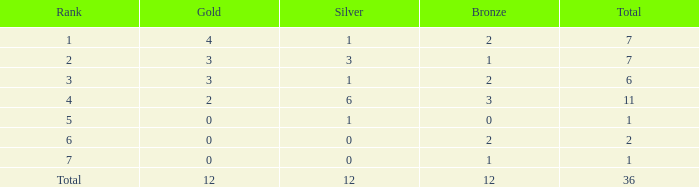Would you mind parsing the complete table? {'header': ['Rank', 'Gold', 'Silver', 'Bronze', 'Total'], 'rows': [['1', '4', '1', '2', '7'], ['2', '3', '3', '1', '7'], ['3', '3', '1', '2', '6'], ['4', '2', '6', '3', '11'], ['5', '0', '1', '0', '1'], ['6', '0', '0', '2', '2'], ['7', '0', '0', '1', '1'], ['Total', '12', '12', '12', '36']]} What is the highest aggregate for a unit with 1 bronze, 0 gold medals and a rank of 7? None. 